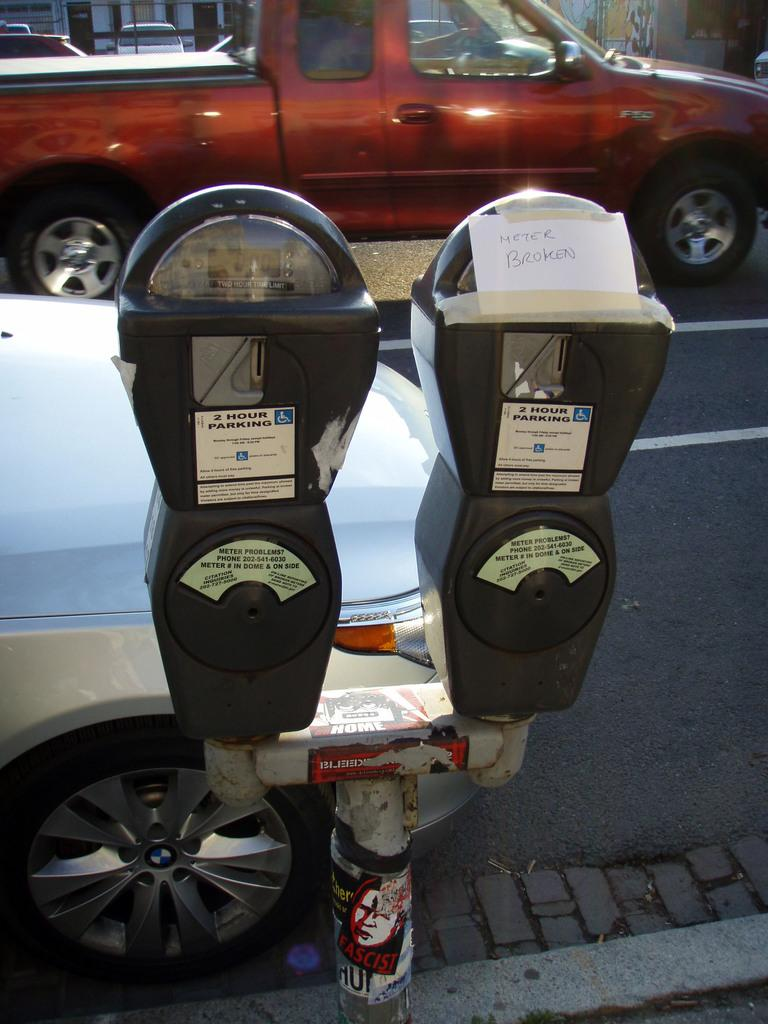<image>
Summarize the visual content of the image. A car parked by two meters and one of them has a sign on it that says Meter Broken. 